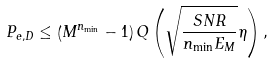Convert formula to latex. <formula><loc_0><loc_0><loc_500><loc_500>P _ { e , D } \leq \left ( M ^ { n _ { \min } } - 1 \right ) Q \left ( \sqrt { \frac { S N R } { n _ { \min } E _ { M } } } \eta \right ) ,</formula> 